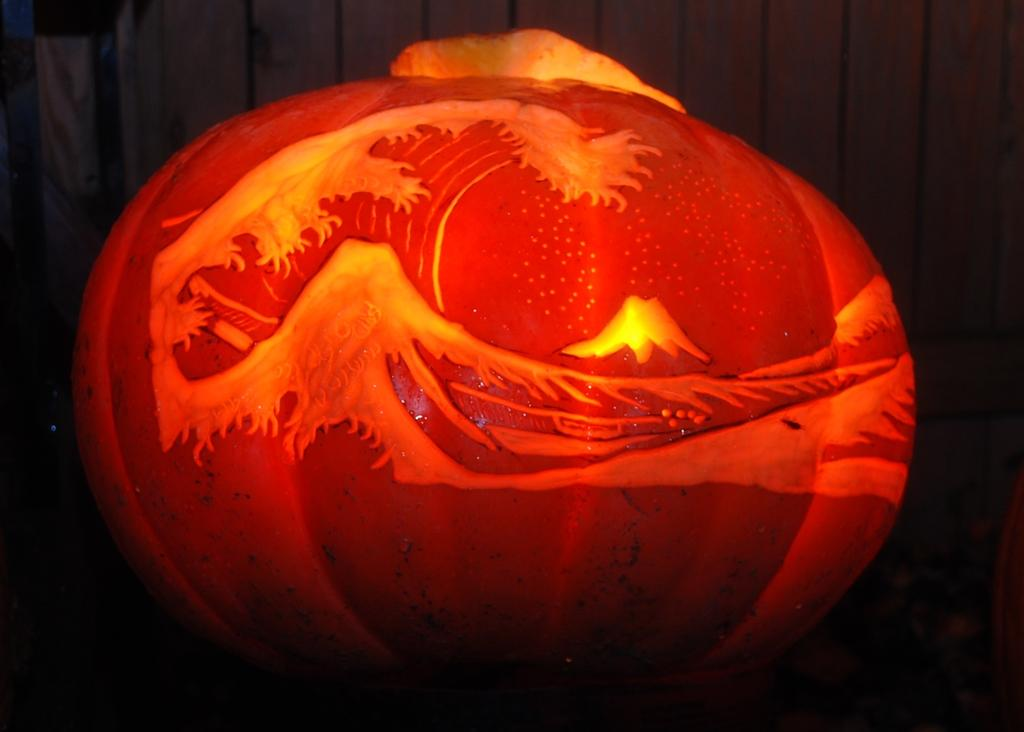What is the main subject of the image? The main subject of the image is a pumpkin. How is the pumpkin decorated? The pumpkin is decorated with paint. What channel is the pumpkin watching in the image? There is no indication in the image that the pumpkin is watching a channel, as pumpkins do not have the ability to watch television. 